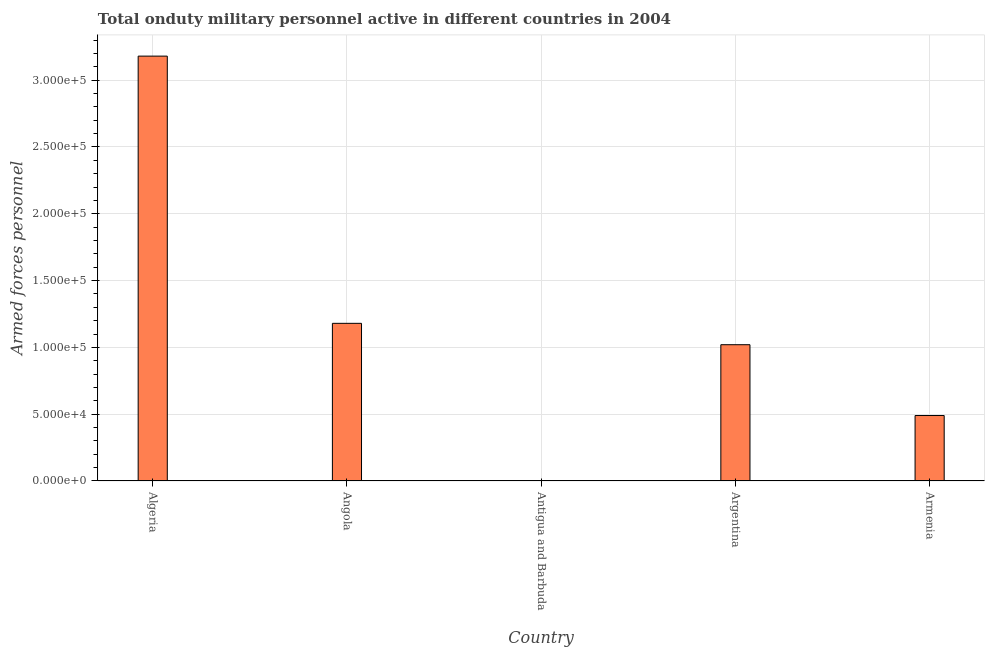Does the graph contain any zero values?
Your answer should be very brief. No. What is the title of the graph?
Provide a succinct answer. Total onduty military personnel active in different countries in 2004. What is the label or title of the X-axis?
Ensure brevity in your answer.  Country. What is the label or title of the Y-axis?
Provide a succinct answer. Armed forces personnel. What is the number of armed forces personnel in Antigua and Barbuda?
Your answer should be very brief. 170. Across all countries, what is the maximum number of armed forces personnel?
Provide a short and direct response. 3.18e+05. Across all countries, what is the minimum number of armed forces personnel?
Offer a very short reply. 170. In which country was the number of armed forces personnel maximum?
Offer a terse response. Algeria. In which country was the number of armed forces personnel minimum?
Your answer should be very brief. Antigua and Barbuda. What is the sum of the number of armed forces personnel?
Offer a terse response. 5.87e+05. What is the difference between the number of armed forces personnel in Angola and Argentina?
Make the answer very short. 1.60e+04. What is the average number of armed forces personnel per country?
Your answer should be very brief. 1.17e+05. What is the median number of armed forces personnel?
Make the answer very short. 1.02e+05. In how many countries, is the number of armed forces personnel greater than 90000 ?
Ensure brevity in your answer.  3. What is the ratio of the number of armed forces personnel in Angola to that in Argentina?
Keep it short and to the point. 1.16. Is the difference between the number of armed forces personnel in Argentina and Armenia greater than the difference between any two countries?
Keep it short and to the point. No. Is the sum of the number of armed forces personnel in Angola and Armenia greater than the maximum number of armed forces personnel across all countries?
Keep it short and to the point. No. What is the difference between the highest and the lowest number of armed forces personnel?
Your answer should be very brief. 3.18e+05. In how many countries, is the number of armed forces personnel greater than the average number of armed forces personnel taken over all countries?
Your answer should be compact. 2. How many bars are there?
Your response must be concise. 5. What is the difference between two consecutive major ticks on the Y-axis?
Your answer should be very brief. 5.00e+04. Are the values on the major ticks of Y-axis written in scientific E-notation?
Offer a terse response. Yes. What is the Armed forces personnel in Algeria?
Give a very brief answer. 3.18e+05. What is the Armed forces personnel in Angola?
Offer a very short reply. 1.18e+05. What is the Armed forces personnel in Antigua and Barbuda?
Offer a terse response. 170. What is the Armed forces personnel of Argentina?
Keep it short and to the point. 1.02e+05. What is the Armed forces personnel of Armenia?
Offer a very short reply. 4.90e+04. What is the difference between the Armed forces personnel in Algeria and Angola?
Your response must be concise. 2.00e+05. What is the difference between the Armed forces personnel in Algeria and Antigua and Barbuda?
Ensure brevity in your answer.  3.18e+05. What is the difference between the Armed forces personnel in Algeria and Argentina?
Provide a short and direct response. 2.16e+05. What is the difference between the Armed forces personnel in Algeria and Armenia?
Provide a succinct answer. 2.69e+05. What is the difference between the Armed forces personnel in Angola and Antigua and Barbuda?
Provide a succinct answer. 1.18e+05. What is the difference between the Armed forces personnel in Angola and Argentina?
Ensure brevity in your answer.  1.60e+04. What is the difference between the Armed forces personnel in Angola and Armenia?
Give a very brief answer. 6.90e+04. What is the difference between the Armed forces personnel in Antigua and Barbuda and Argentina?
Ensure brevity in your answer.  -1.02e+05. What is the difference between the Armed forces personnel in Antigua and Barbuda and Armenia?
Your answer should be compact. -4.88e+04. What is the difference between the Armed forces personnel in Argentina and Armenia?
Give a very brief answer. 5.30e+04. What is the ratio of the Armed forces personnel in Algeria to that in Angola?
Provide a succinct answer. 2.69. What is the ratio of the Armed forces personnel in Algeria to that in Antigua and Barbuda?
Provide a succinct answer. 1870.59. What is the ratio of the Armed forces personnel in Algeria to that in Argentina?
Give a very brief answer. 3.12. What is the ratio of the Armed forces personnel in Algeria to that in Armenia?
Ensure brevity in your answer.  6.49. What is the ratio of the Armed forces personnel in Angola to that in Antigua and Barbuda?
Keep it short and to the point. 694.12. What is the ratio of the Armed forces personnel in Angola to that in Argentina?
Your response must be concise. 1.16. What is the ratio of the Armed forces personnel in Angola to that in Armenia?
Offer a terse response. 2.41. What is the ratio of the Armed forces personnel in Antigua and Barbuda to that in Argentina?
Ensure brevity in your answer.  0. What is the ratio of the Armed forces personnel in Antigua and Barbuda to that in Armenia?
Keep it short and to the point. 0. What is the ratio of the Armed forces personnel in Argentina to that in Armenia?
Provide a short and direct response. 2.08. 